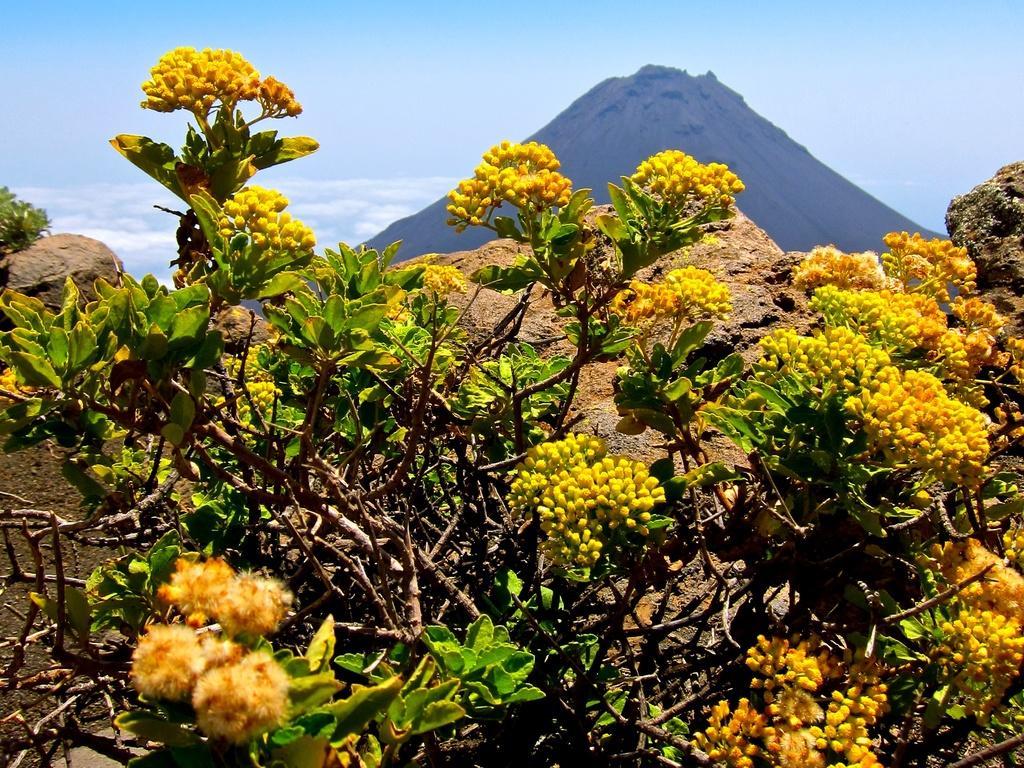Can you describe this image briefly? We can see plants, flowers and buds. In the background we can see hill and sky. 